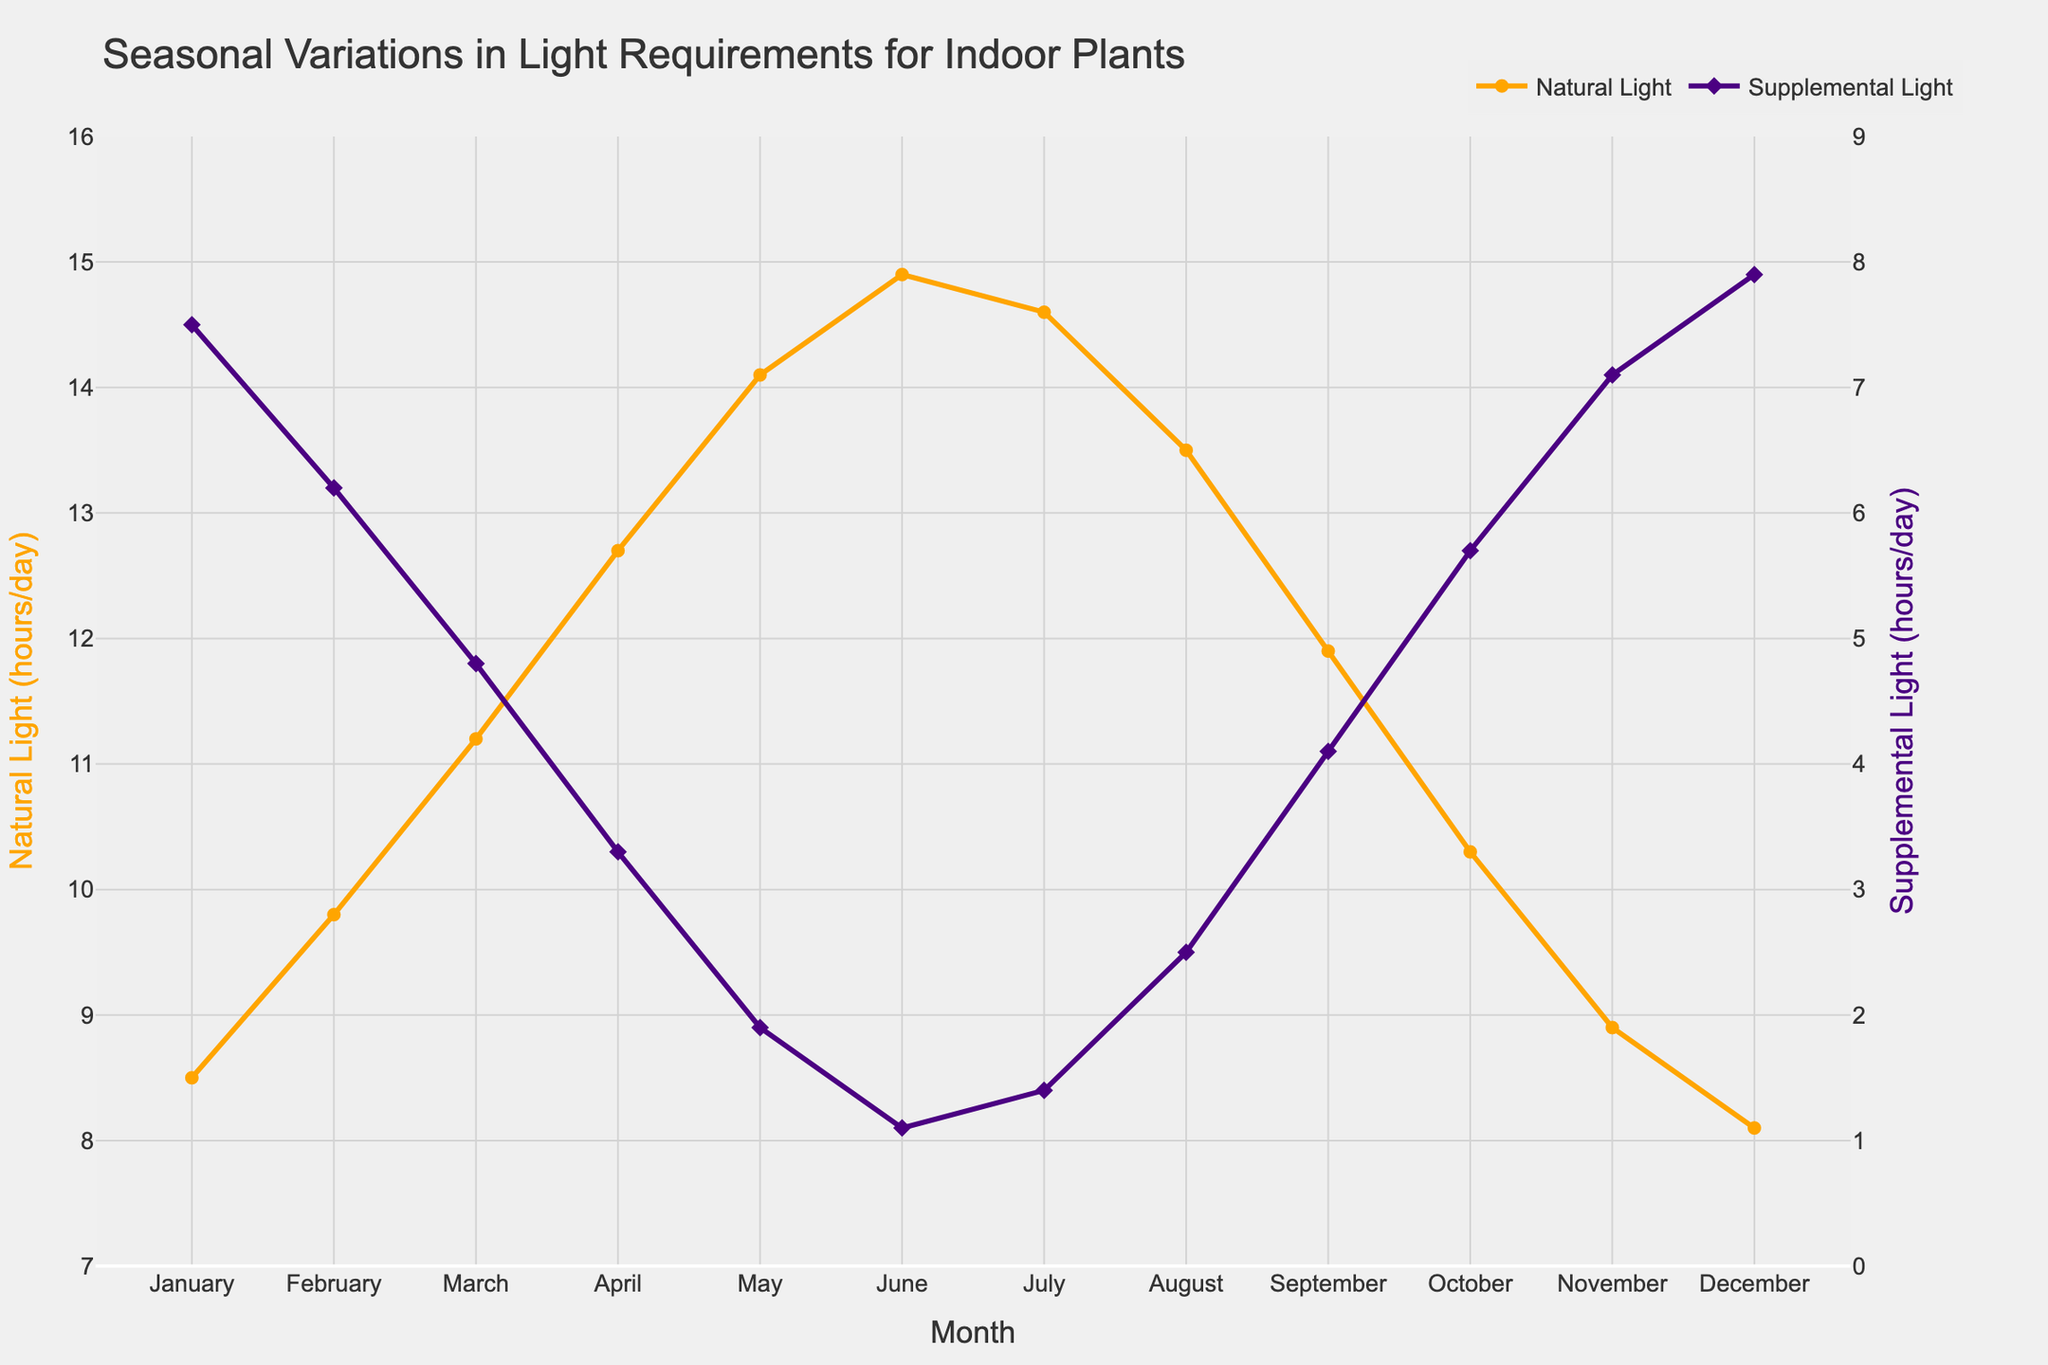Which month requires the most supplemental light? To determine the month requiring the most supplemental light, look for the highest point on the purple line representing "Supplemental Light (hours/day)". This peak occurs in December.
Answer: December Which month has the lowest amount of natural light? To find the month with the lowest natural light, look for the lowest point on the orange line representing "Natural Light (hours/day)". This lowest point happens in December.
Answer: December In which month do natural light and supplemental light equal their mean values? First, calculate the average values: 
\[ \text{Mean Natural Light} = \frac{8.5 + 9.8 + 11.2 + 12.7 + 14.1 + 14.9 + 14.6 + 13.5 + 11.9 + 10.3 + 8.9 + 8.1}{12} \approx 11.6 \, \text{hours/day} \]
\[ \text{Mean Supplemental Light} = \frac{7.5 + 6.2 + 4.8 + 3.3 + 1.9 + 1.1 + 1.4 + 2.5 + 4.1 + 5.7 + 7.1 + 7.9}{12} \approx 4.4 \, \text{hours/day} \]
Find the months where the lines cross these values. Both values are closest in March.
Answer: March By how many hours does supplemental light reduce from January to May? Subtract the "Supplemental Light" value in May from the value in January: 
\[ 7.5 \, \text{hours/day} - 1.9 \, \text{hours/day} = 5.6 \, \text{hours/day} \]
Answer: 5.6 hours/day Which month has the highest combined total of natural and supplemental light? The "Natural Light" and "Supplemental Light" lines combine to give a constant total light requirement of 16 hours/day in each month.
Answer: All months During which month is the gap between natural light and supplemental light the smallest? Look for the months where the orange and purple lines are closest together. This happens in June where the natural light is 14.9 hours/day and the supplemental light is 1.1 hours/day.
Answer: June From February to March, how does the natural light increase compare to the decrease in supplemental light? Calculate the increase in natural light from February to March:
\[ 11.2 \, \text{hours/day} - 9.8 \, \text{hours/day} = 1.4 \, \text{hours/day} \]
Calculate the decrease in supplemental light from February to March:
\[ 6.2 \, \text{hours/day} - 4.8  \, \text{hours/day} = 1.4 \, \text{hours/day} \] 
Both changes are equal.
Answer: Equal Does July show an increase or decrease in natural light compared to June? Compare the natural light value in July to June: 
\[ 14.6 \, \text{hours/day} \, (\text{July}) \] vs. 
\[ 14.9 \, \text{hours/day} \, (\text{June}) \] 
So, natural light decreases in July.
Answer: Decrease What is the total supplemental light required from January to June? Add the supplemental light values from January to June: 
\[ 7.5 + 6.2 + 4.8 + 3.3 + 1.9 + 1.1 = 24.8 \, \text{hours/day} \]
Answer: 24.8 hours/day 